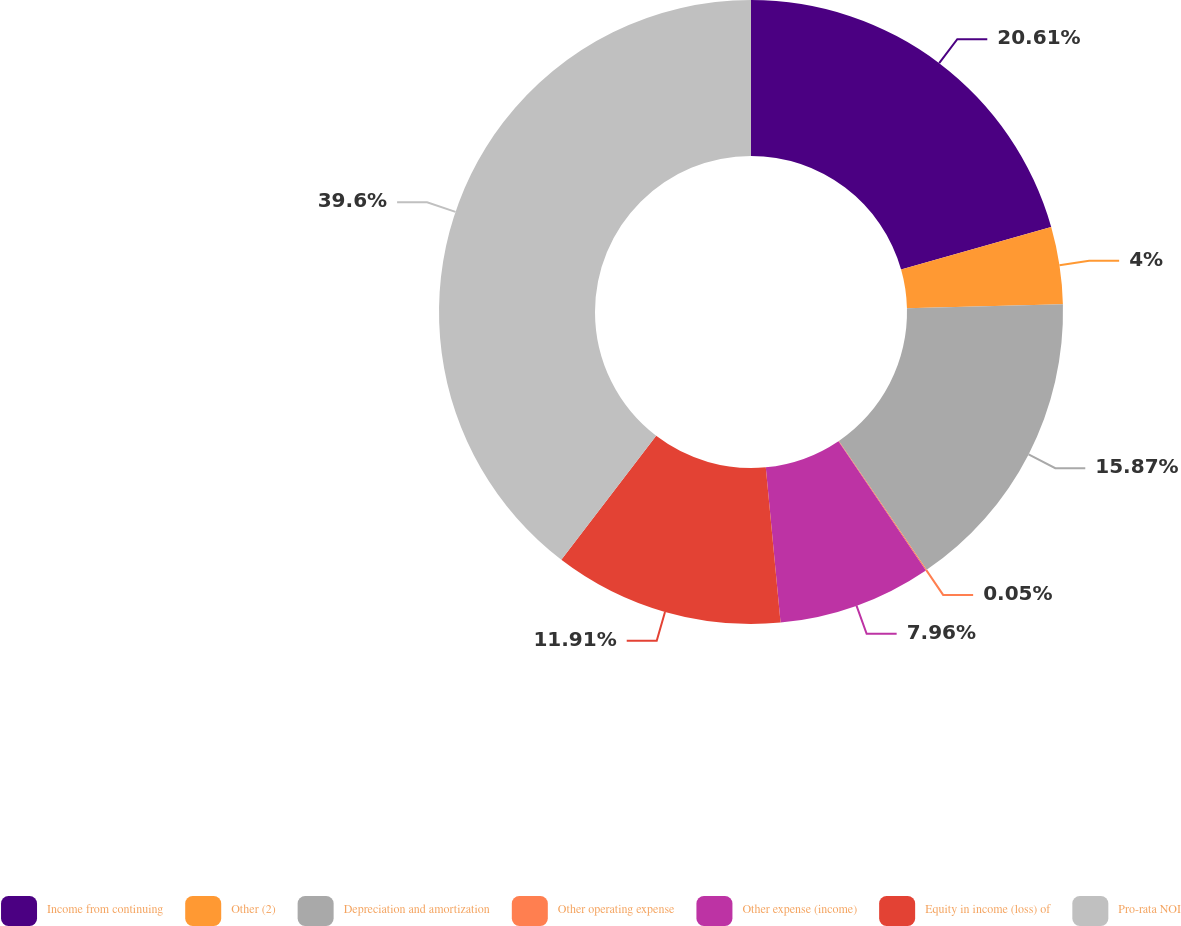Convert chart. <chart><loc_0><loc_0><loc_500><loc_500><pie_chart><fcel>Income from continuing<fcel>Other (2)<fcel>Depreciation and amortization<fcel>Other operating expense<fcel>Other expense (income)<fcel>Equity in income (loss) of<fcel>Pro-rata NOI<nl><fcel>20.61%<fcel>4.0%<fcel>15.87%<fcel>0.05%<fcel>7.96%<fcel>11.91%<fcel>39.6%<nl></chart> 